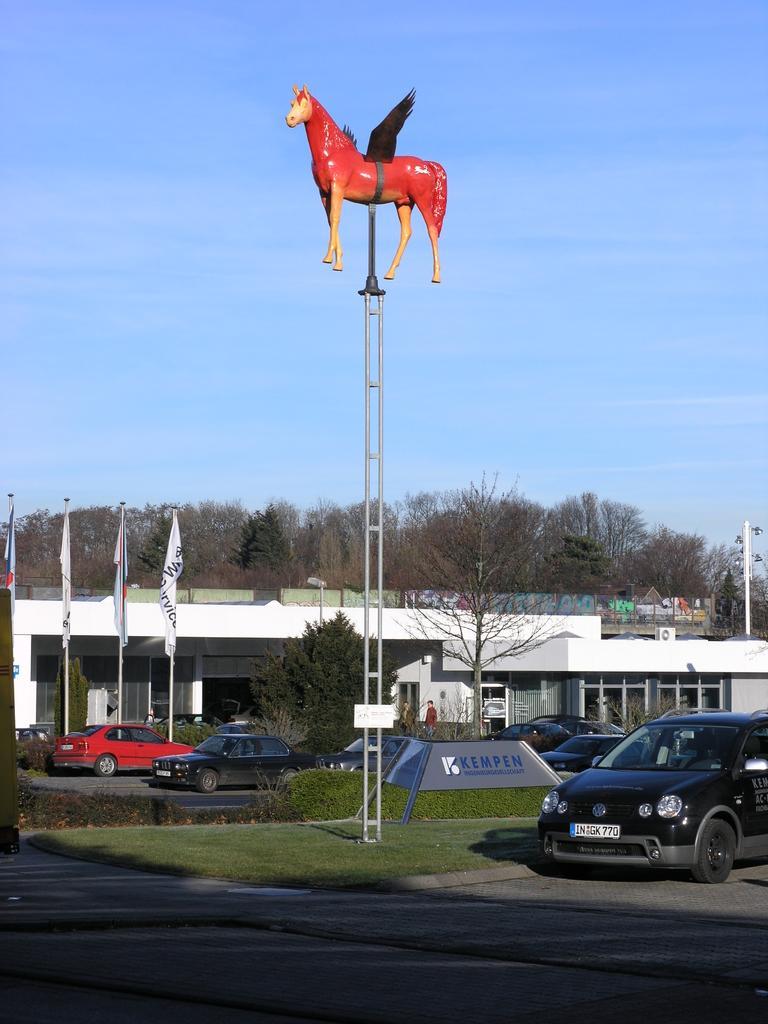Could you give a brief overview of what you see in this image? In the foreground of this image, there is a vehicle moving on the road and also an idol a horse consisting of wings is on a pole. In the background, there are vehicles moving on the road, grass land, plants, trees, flags, buildings and the sky. 